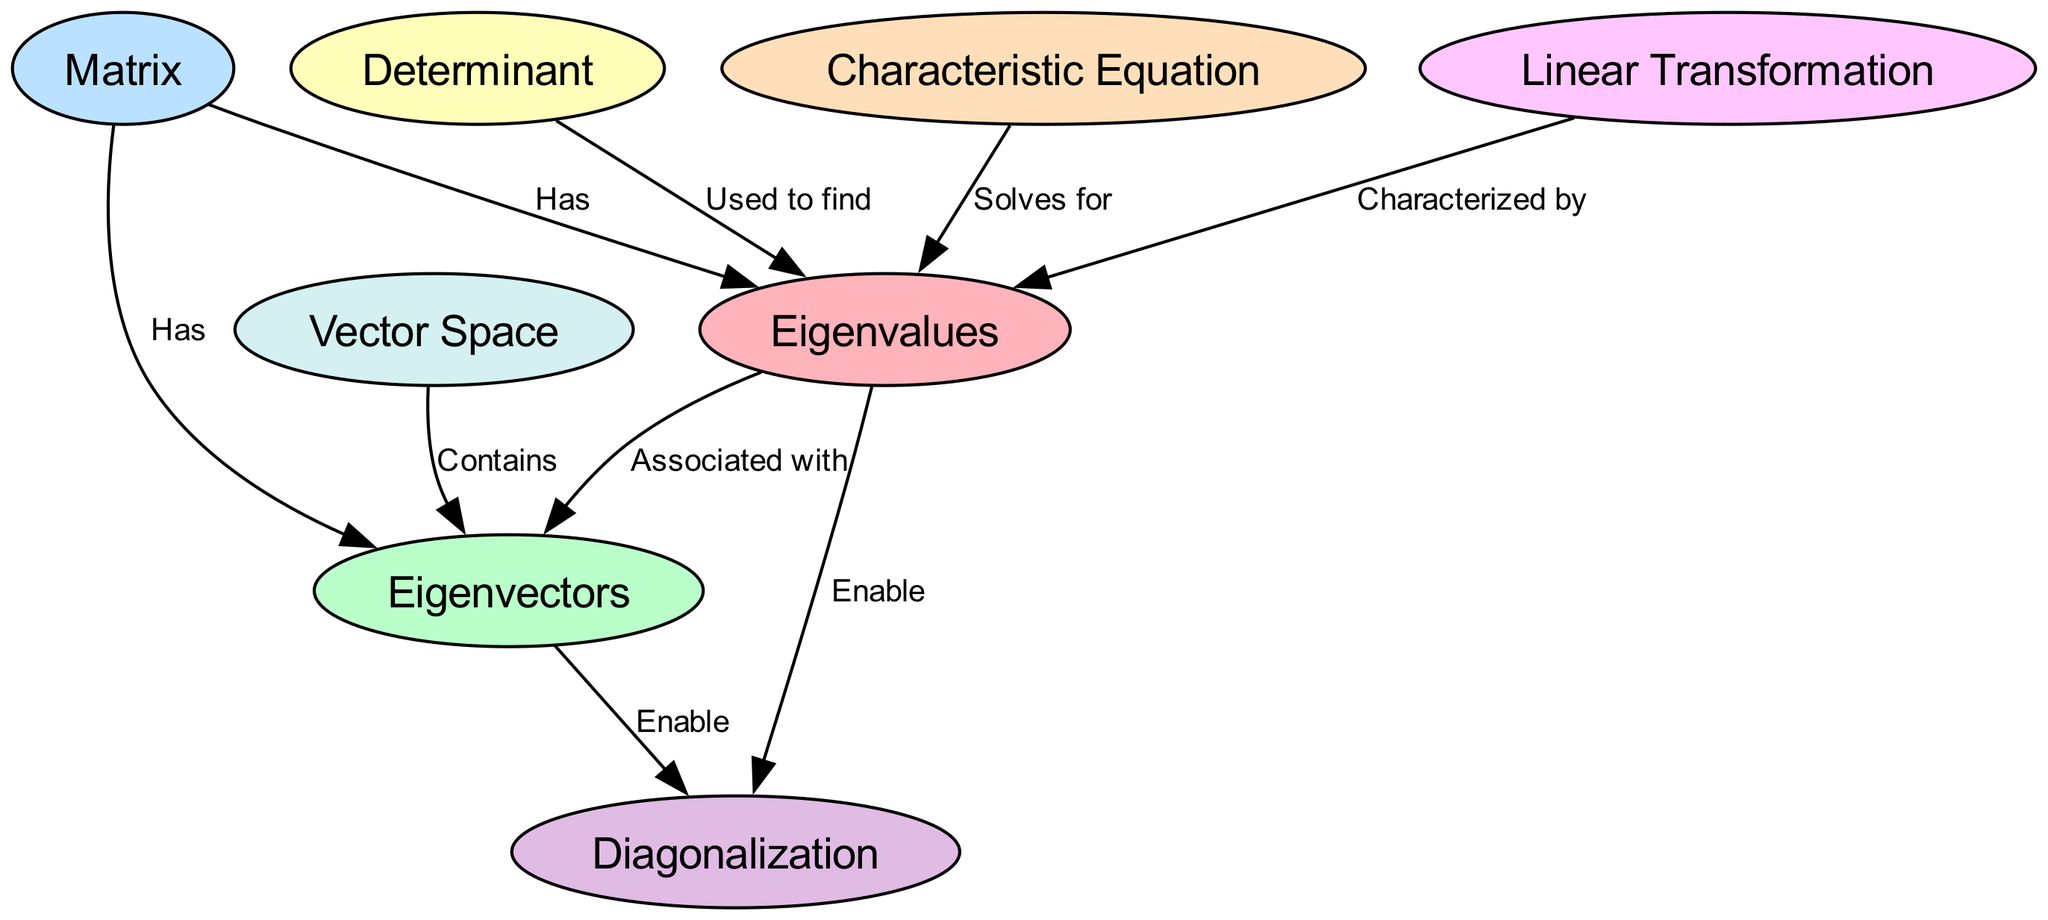What are the two central nodes in the diagram? The diagram features 'Eigenvalues' and 'Eigenvectors' as its central nodes. By identifying the structural layout of the diagram, it's noted that these two nodes serve as pivotal concepts connected to many others.
Answer: Eigenvalues and Eigenvectors How many nodes are present in the diagram? To find the number of nodes, we can count them in the provided data under the "nodes" section. There are a total of eight distinct nodes listed.
Answer: Eight What relationship does the 'Determinant' node have with the 'Eigenvalues' node? In the diagram, there’s a directed edge from 'Determinant' to 'Eigenvalues' labeled 'Used to find'. This signifies that the determinant plays a role in the calculation or discovery of eigenvalues.
Answer: Used to find Which node enables 'Diagonalization' in the diagram? Looking at the edges leading to 'Diagonalization', we can see that both 'Eigenvalues' and 'Eigenvectors' have directed edges labeled 'Enable' towards 'Diagonalization'. Therefore, both of these nodes contribute to this concept.
Answer: Eigenvalues and Eigenvectors What does the 'Characteristic Equation' node do concerning 'Eigenvalues'? There is a directed edge from 'Characteristic Equation' to 'Eigenvalues' with the label 'Solves for'. This indicates that the characteristic equation is used specifically to determine the eigenvalues of a given matrix.
Answer: Solves for How does 'Linear Transformation' relate to 'Eigenvalues'? The edge connecting 'Linear Transformation' to 'Eigenvalues' is labeled 'Characterized by'. This suggests that linear transformations are described or classified using the concept of eigenvalues.
Answer: Characterized by What does the 'Vector Space' contain according to the diagram? The relationship noted between 'Vector Space' and 'Eigenvectors' is expressed with the label 'Contains'. This indicates that eigenvectors are elements within the broader context of vector spaces.
Answer: Contains Which nodes are associated with 'Matrix' in the diagram? There are direct connections from 'Matrix' to both 'Eigenvalues' and 'Eigenvectors' labeled 'Has'. This shows that matrices have a relationship with both of these concepts, implying that they are significant attributes of matrices in linear algebra.
Answer: Eigenvalues and Eigenvectors 